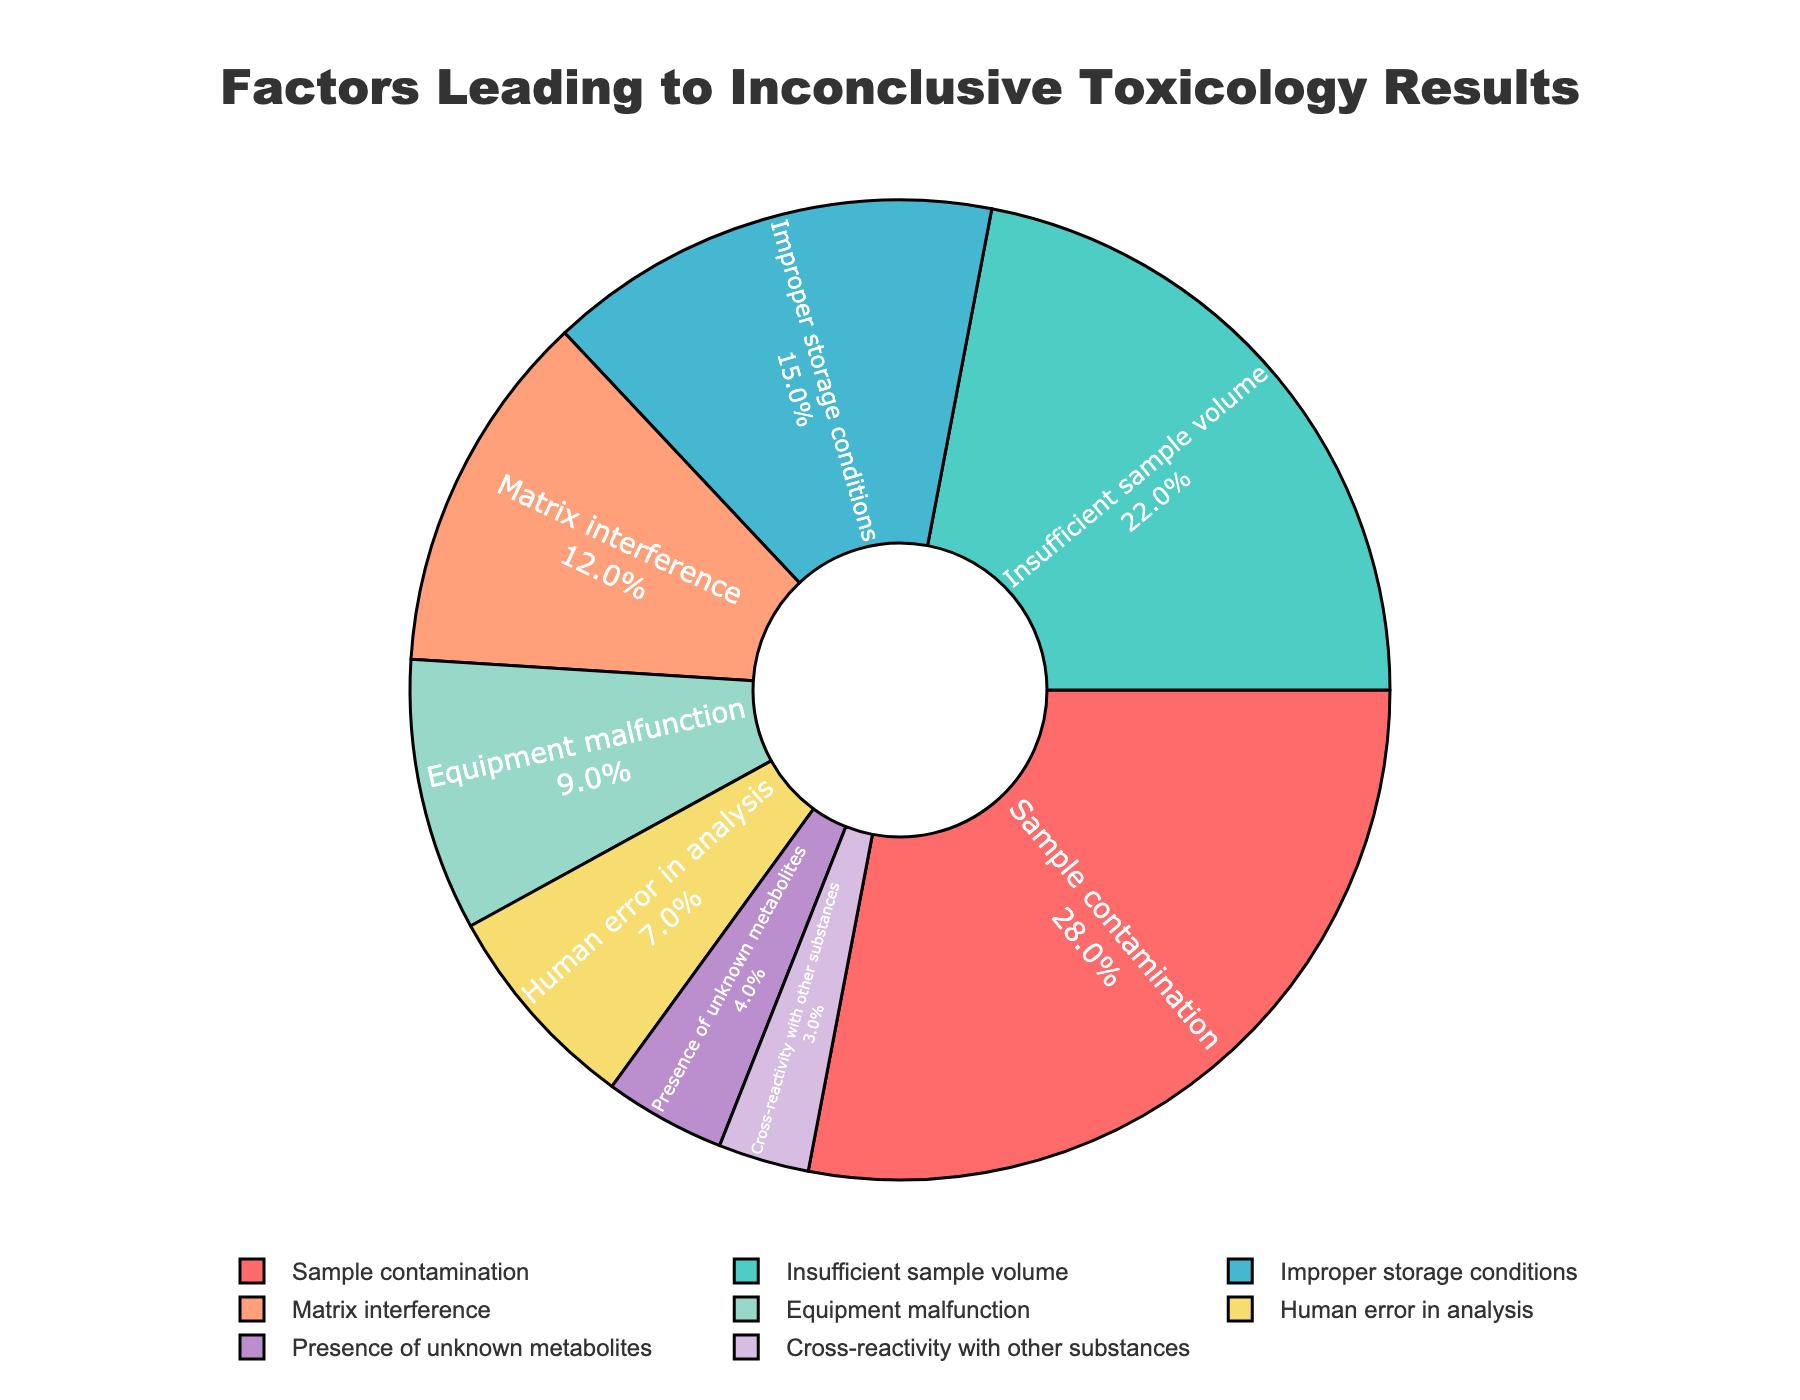What's the most frequent factor leading to inconclusive toxicology test results? The "Sample contamination" slice is the largest in the pie chart with a percentage of 28%.
Answer: Sample contamination Which factor accounts for exactly 12% of the inconclusive toxicology test results? The "Matrix interference" slice shows 12% on the pie chart.
Answer: Matrix interference What is the combined percentage of results caused by "Equipment malfunction" and "Human error in analysis"? "Equipment malfunction" is 9% and "Human error in analysis" is 7%. Adding these gives 9% + 7% = 16%.
Answer: 16% How does the percentage of "Insufficient sample volume" compare to "Improper storage conditions"? "Insufficient sample volume" is 22%, while "Improper storage conditions" is 15%. 22% is greater than 15%.
Answer: Greater Which factor has the smallest representation in the pie chart? The "Cross-reactivity with other substances" slice is the smallest with 3%.
Answer: Cross-reactivity with other substances Determine the cumulative percentage covered by the three least frequent factors. The three least frequent factors are "Presence of unknown metabolites" (4%), "Cross-reactivity with other substances" (3%), and "Human error in analysis" (7%). Adding these gives 4% + 3% + 7% = 14%.
Answer: 14% Is the percentage of "Improper storage conditions" closer to that of "Matrix interference" or "Insufficient sample volume"? "Improper storage conditions" is 15%, "Matrix interference" is 12%, and "Insufficient sample volume" is 22%. The difference between "Improper storage conditions" and "Matrix interference" is 15% - 12% = 3%. The difference between "Improper storage conditions" and "Insufficient sample volume" is 22% - 15% = 7%. Hence, it is closer to "Matrix interference".
Answer: Matrix interference Which type of error is labeled with the teal color in the pie chart? The teal color corresponds to "Insufficient sample volume," which is 22% in the pie chart.
Answer: Insufficient sample volume 